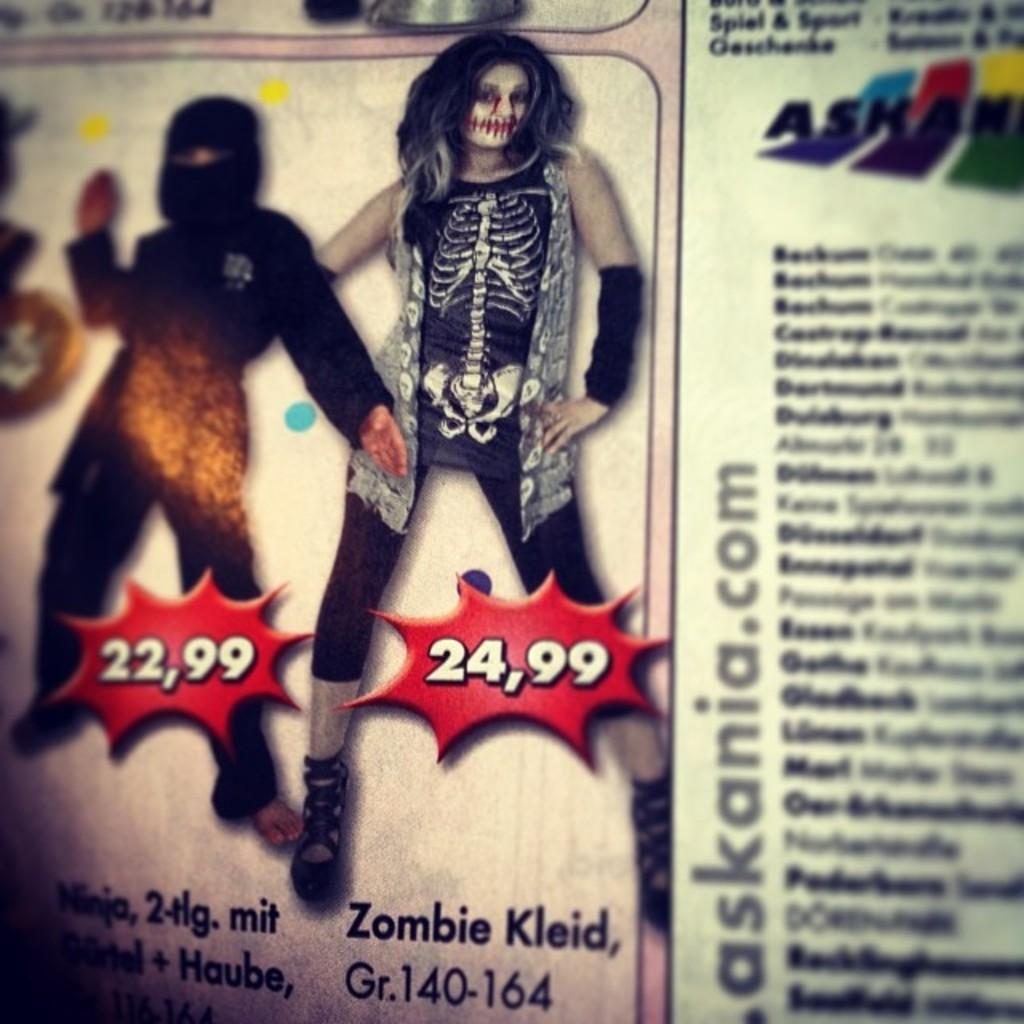How many people are in the image? There are two persons standing in the image. What is the color and description of the object below the persons? There is a red object with writing below the persons. Is there any text present in the image? Yes, there is writing in the right corner of the image. How do the persons in the image sort the items on the table? There is no table or items present in the image, so it is not possible to determine how the persons might sort anything. 